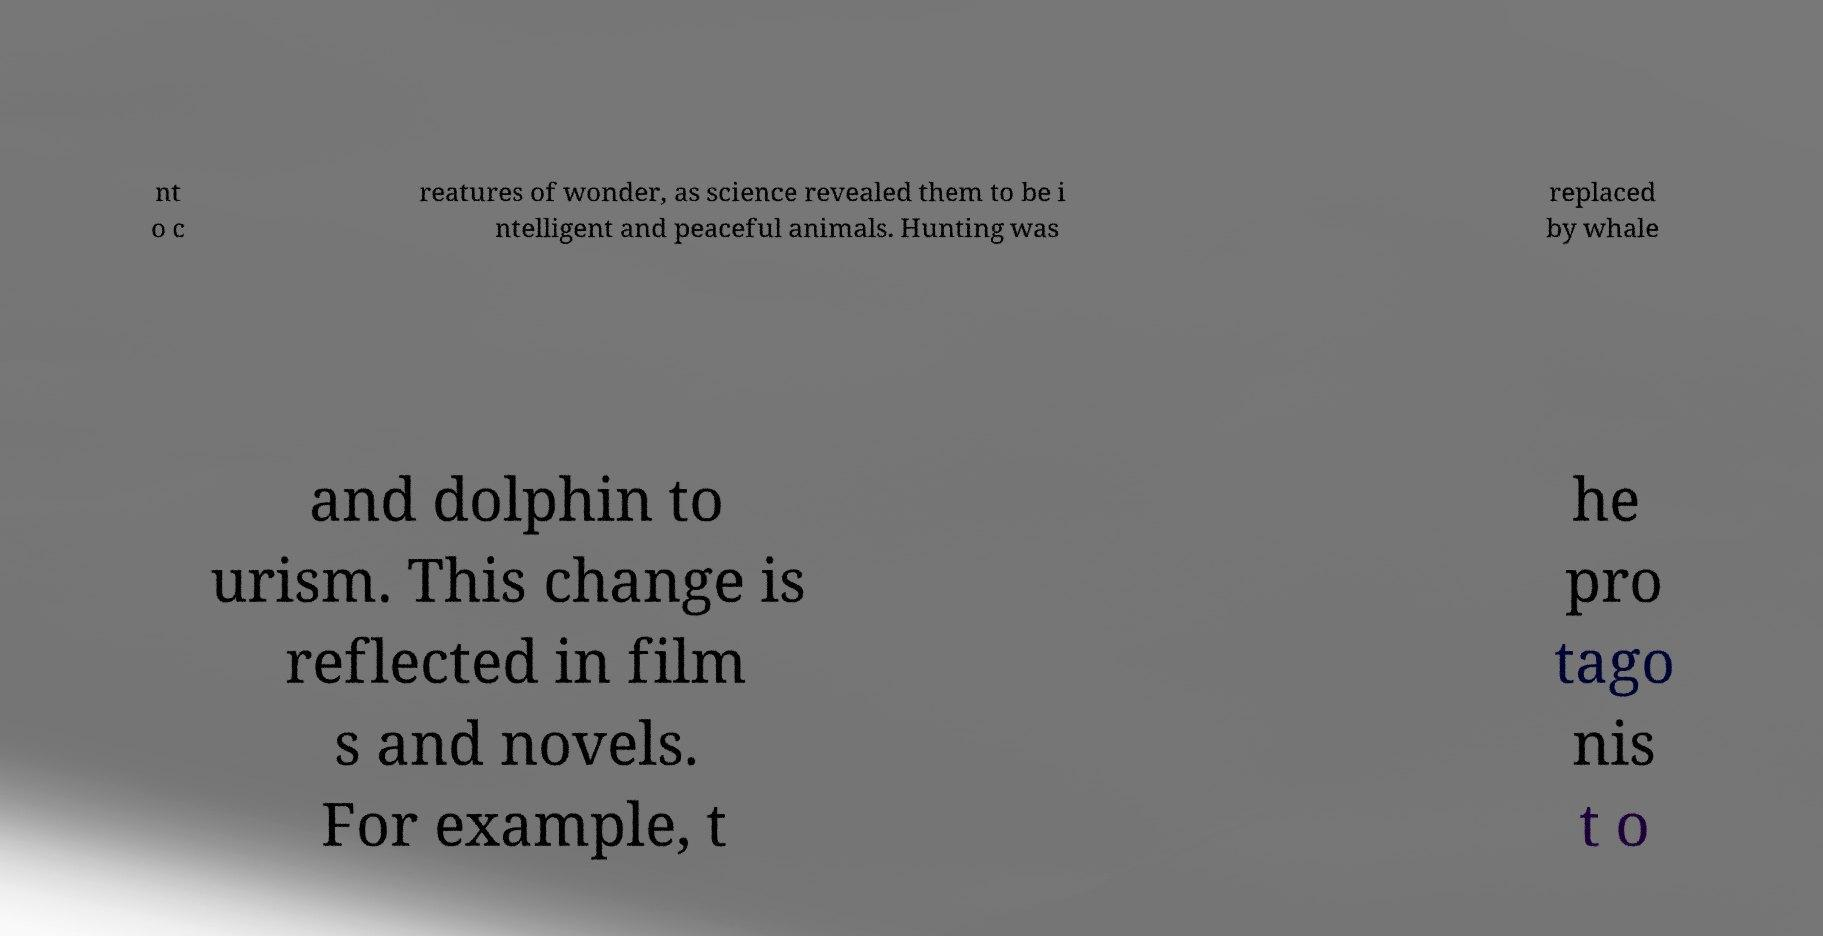For documentation purposes, I need the text within this image transcribed. Could you provide that? nt o c reatures of wonder, as science revealed them to be i ntelligent and peaceful animals. Hunting was replaced by whale and dolphin to urism. This change is reflected in film s and novels. For example, t he pro tago nis t o 